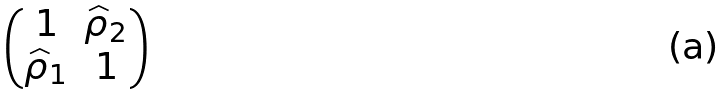<formula> <loc_0><loc_0><loc_500><loc_500>\begin{pmatrix} 1 & \widehat { \rho } _ { 2 } \\ \widehat { \rho } _ { 1 } & 1 \end{pmatrix}</formula> 